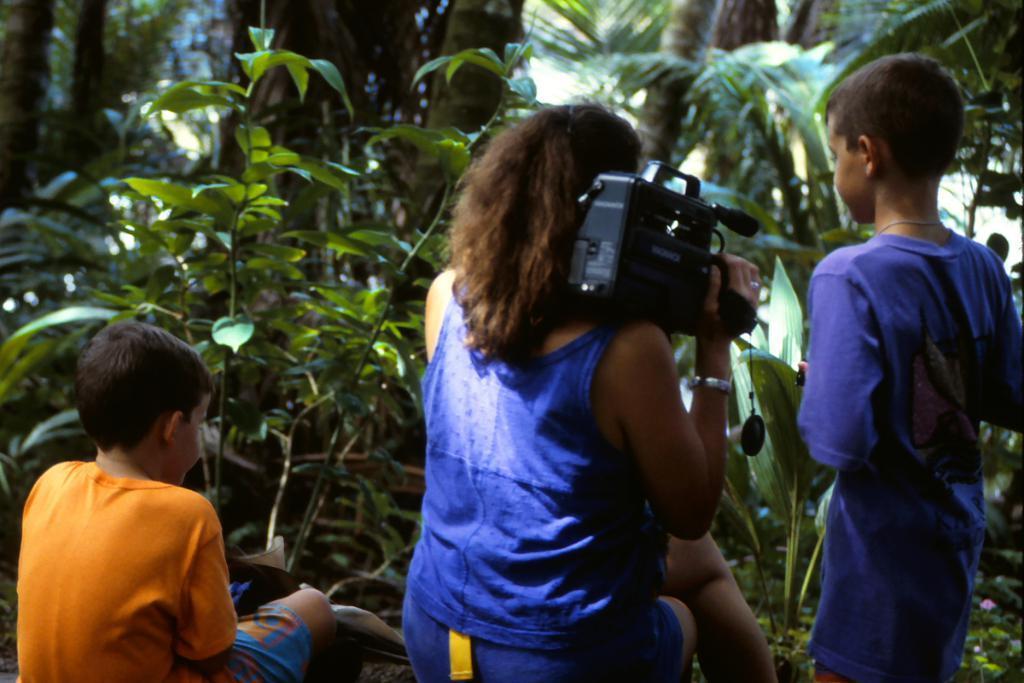How would you summarize this image in a sentence or two? There are three persons. She is holding a camera with her hand. These are the plants. 